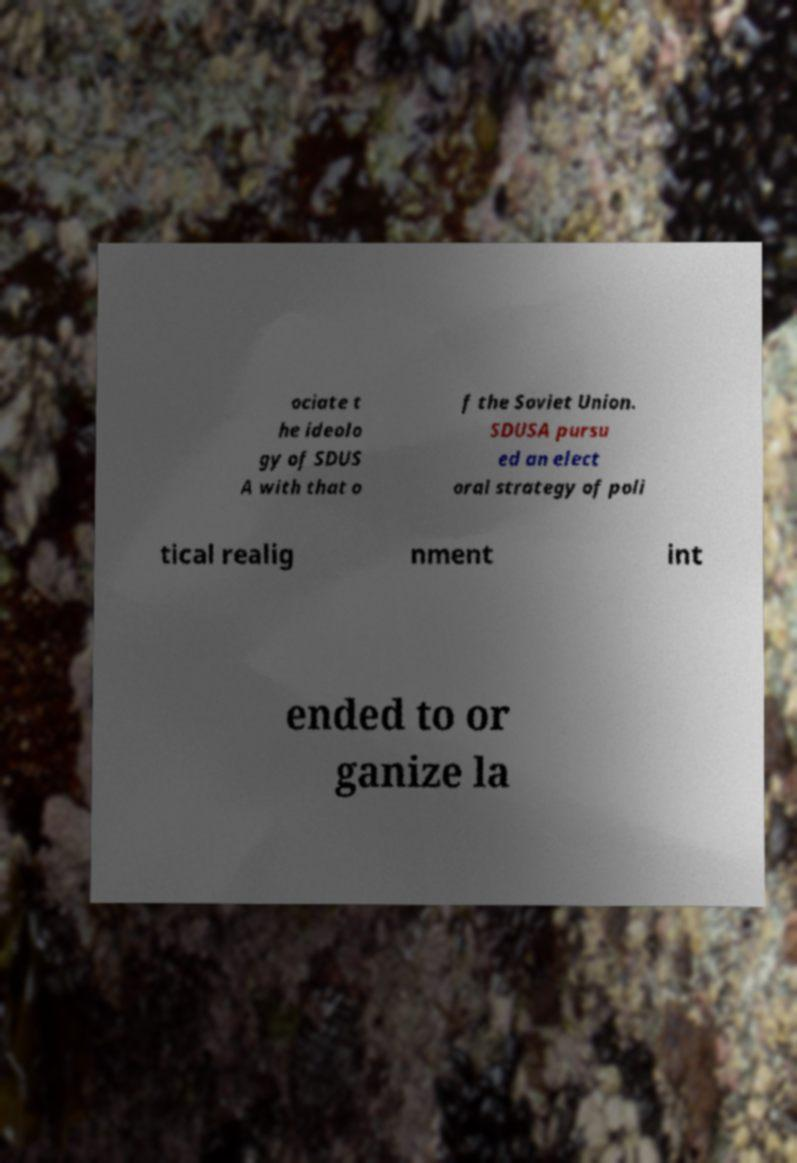Can you read and provide the text displayed in the image?This photo seems to have some interesting text. Can you extract and type it out for me? ociate t he ideolo gy of SDUS A with that o f the Soviet Union. SDUSA pursu ed an elect oral strategy of poli tical realig nment int ended to or ganize la 